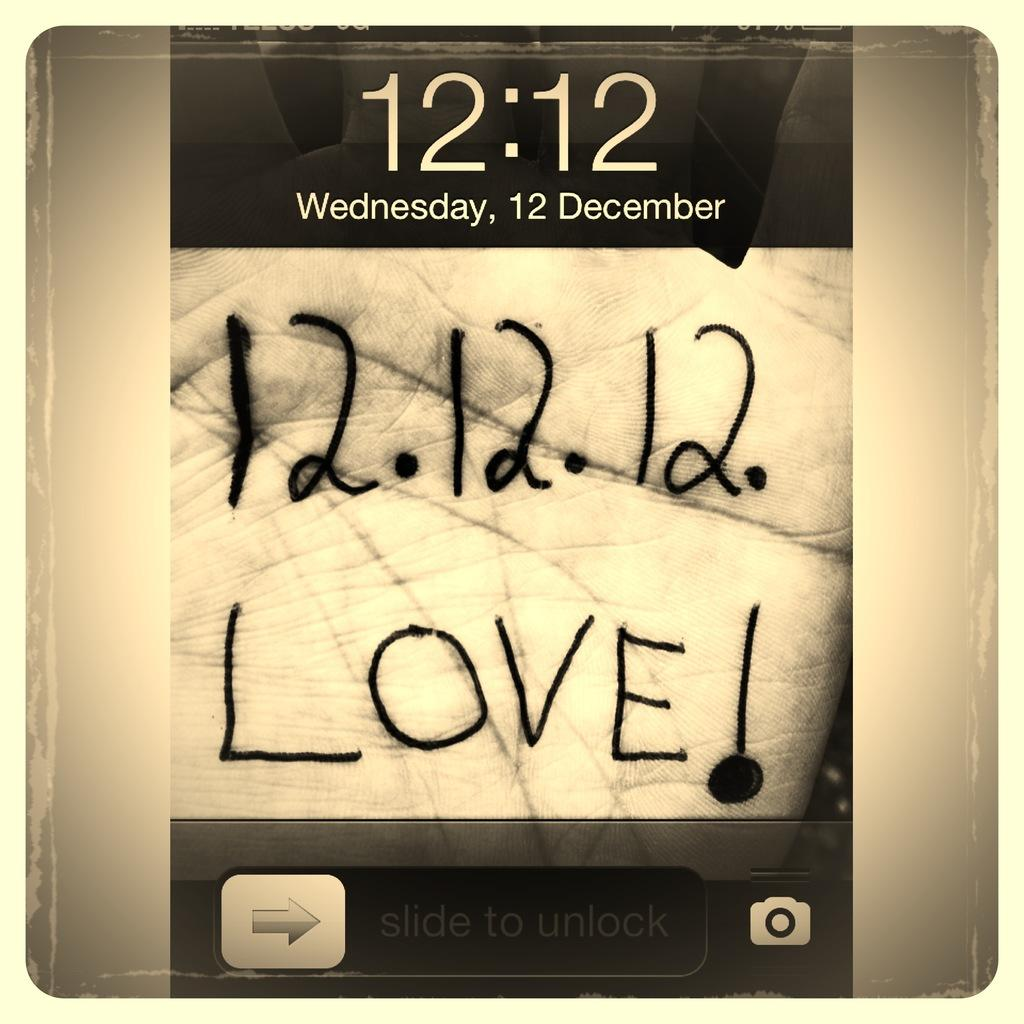<image>
Describe the image concisely. a close up of a cell phone screen reading 12.12.12 LOVE! 